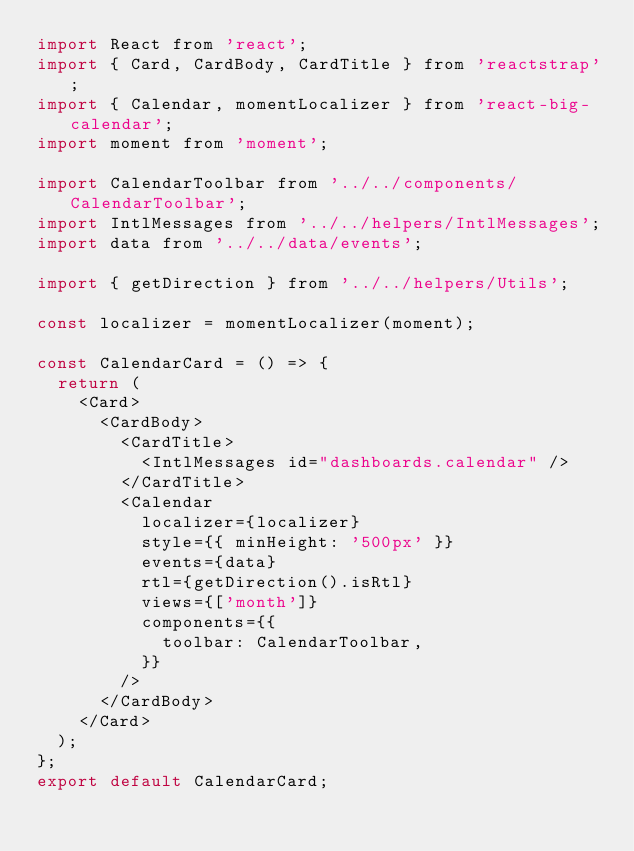Convert code to text. <code><loc_0><loc_0><loc_500><loc_500><_JavaScript_>import React from 'react';
import { Card, CardBody, CardTitle } from 'reactstrap';
import { Calendar, momentLocalizer } from 'react-big-calendar';
import moment from 'moment';

import CalendarToolbar from '../../components/CalendarToolbar';
import IntlMessages from '../../helpers/IntlMessages';
import data from '../../data/events';

import { getDirection } from '../../helpers/Utils';

const localizer = momentLocalizer(moment);

const CalendarCard = () => {
  return (
    <Card>
      <CardBody>
        <CardTitle>
          <IntlMessages id="dashboards.calendar" />
        </CardTitle>
        <Calendar
          localizer={localizer}
          style={{ minHeight: '500px' }}
          events={data}
          rtl={getDirection().isRtl}
          views={['month']}
          components={{
            toolbar: CalendarToolbar,
          }}
        />
      </CardBody>
    </Card>
  );
};
export default CalendarCard;
</code> 